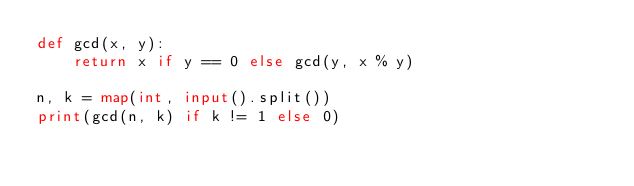<code> <loc_0><loc_0><loc_500><loc_500><_Python_>def gcd(x, y):
    return x if y == 0 else gcd(y, x % y)

n, k = map(int, input().split())
print(gcd(n, k) if k != 1 else 0)</code> 